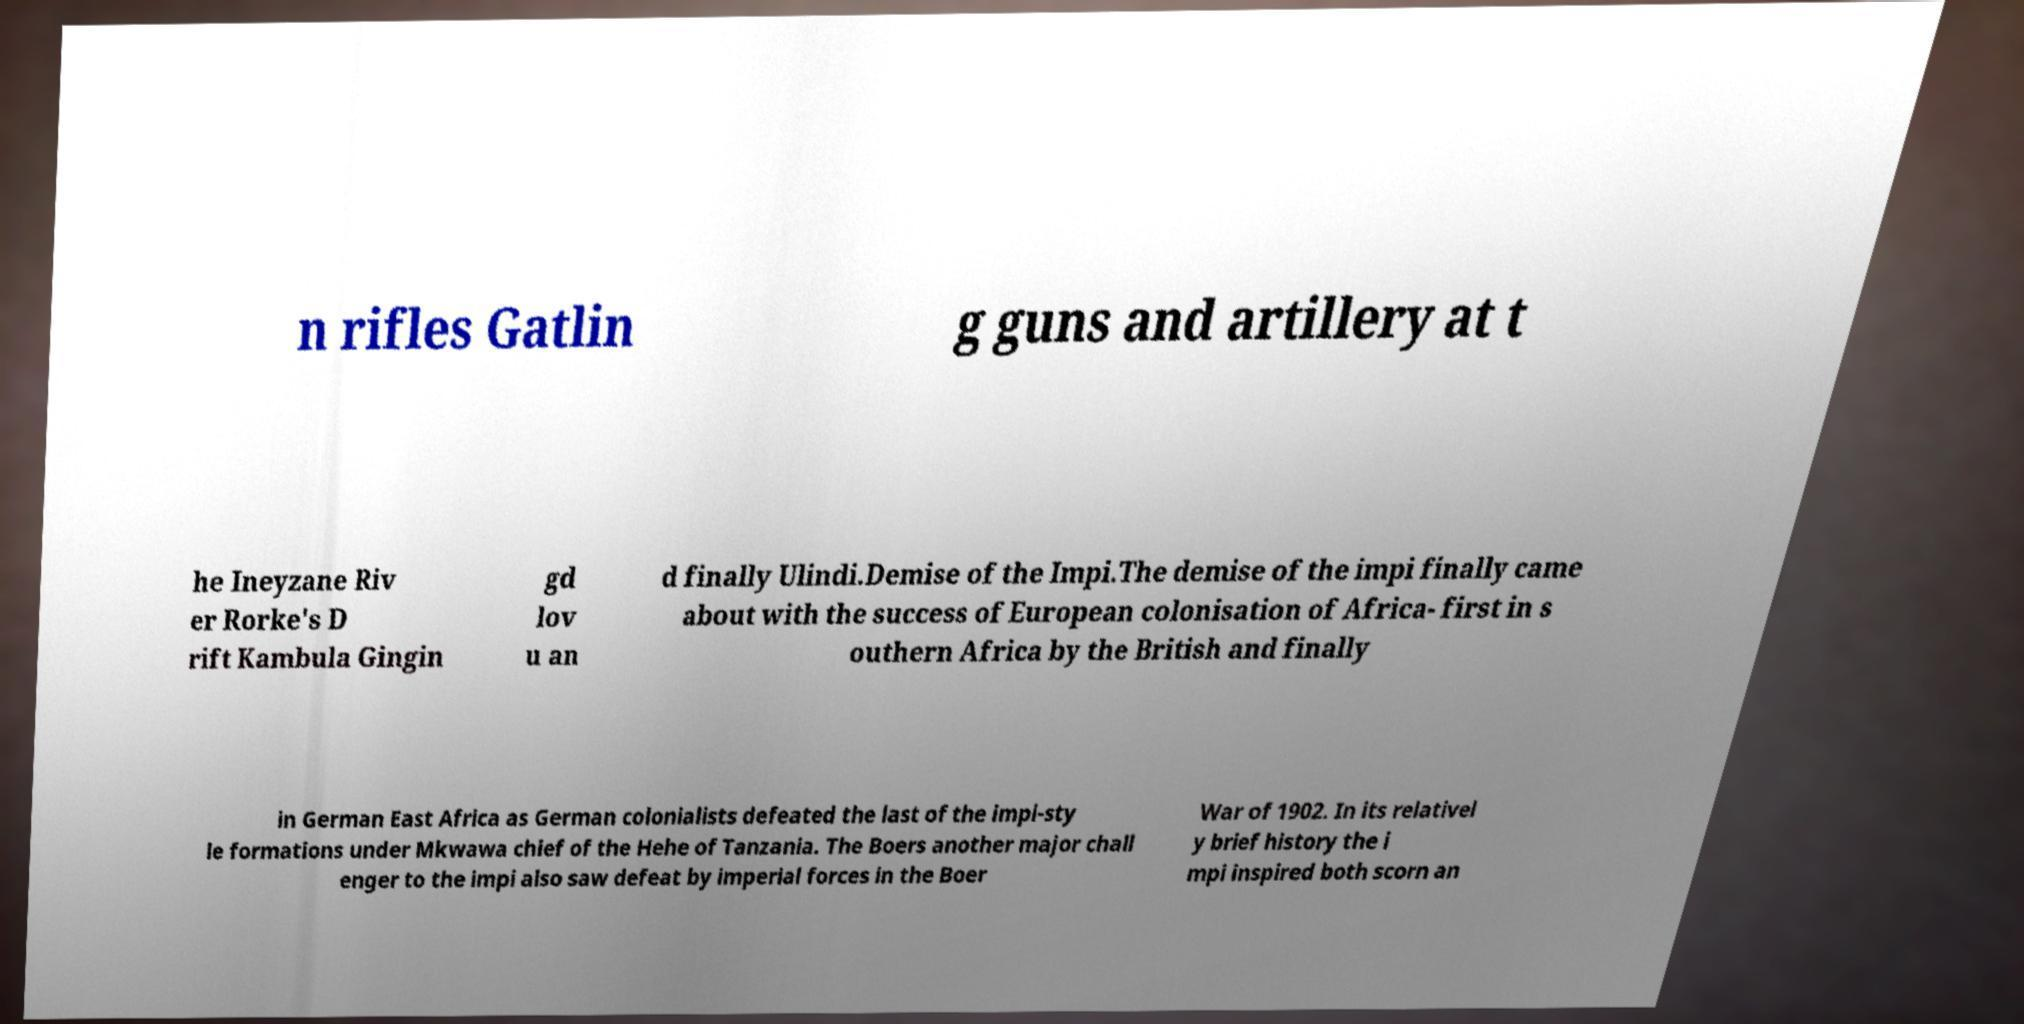Can you accurately transcribe the text from the provided image for me? n rifles Gatlin g guns and artillery at t he Ineyzane Riv er Rorke's D rift Kambula Gingin gd lov u an d finally Ulindi.Demise of the Impi.The demise of the impi finally came about with the success of European colonisation of Africa- first in s outhern Africa by the British and finally in German East Africa as German colonialists defeated the last of the impi-sty le formations under Mkwawa chief of the Hehe of Tanzania. The Boers another major chall enger to the impi also saw defeat by imperial forces in the Boer War of 1902. In its relativel y brief history the i mpi inspired both scorn an 